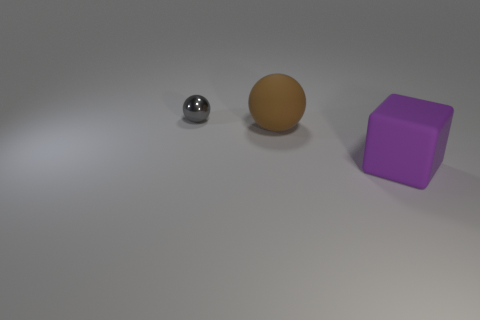What number of other brown matte spheres are the same size as the rubber sphere?
Provide a succinct answer. 0. What size is the object that is behind the big purple matte object and in front of the small gray thing?
Give a very brief answer. Large. There is a large matte thing right of the big brown matte sphere that is behind the big purple rubber object; what number of large objects are left of it?
Provide a short and direct response. 1. Is there a big object that has the same color as the rubber ball?
Offer a terse response. No. The other matte object that is the same size as the purple object is what color?
Offer a terse response. Brown. There is a small gray metal thing behind the big object left of the object that is to the right of the big brown rubber object; what is its shape?
Offer a very short reply. Sphere. How many small metallic things are behind the rubber object behind the large purple thing?
Offer a terse response. 1. There is a big rubber object behind the purple rubber block; is its shape the same as the matte thing that is to the right of the large brown rubber ball?
Offer a terse response. No. What number of gray metallic spheres are in front of the matte sphere?
Ensure brevity in your answer.  0. Do the gray object behind the large matte cube and the brown sphere have the same material?
Provide a succinct answer. No. 